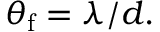<formula> <loc_0><loc_0><loc_500><loc_500>\theta _ { f } = \lambda / d .</formula> 